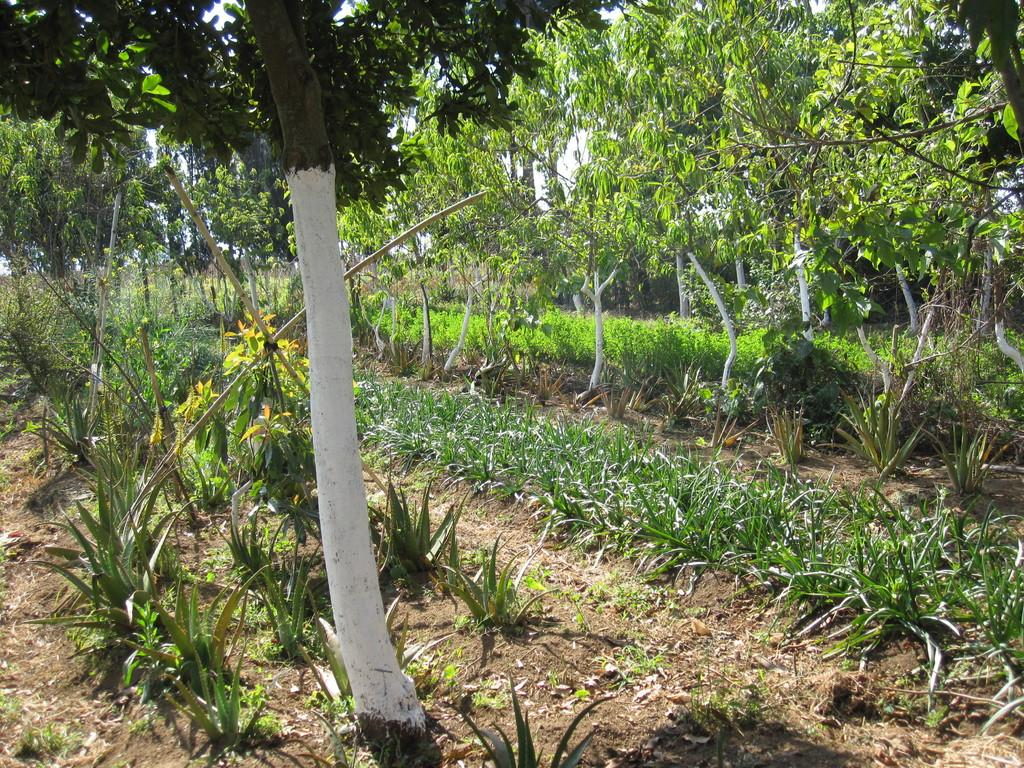What type of plants are featured in the image? There are aloe vera plants in the image. Are there any other types of plants present? Yes, there are other plants in the image. What other natural elements can be seen in the image? There are trees in the image. What is visible in the background of the image? The sky is visible in the background of the image. Where is the crown placed on the aloe vera plant in the image? There is no crown present on the aloe vera plant or any other plants in the image. 